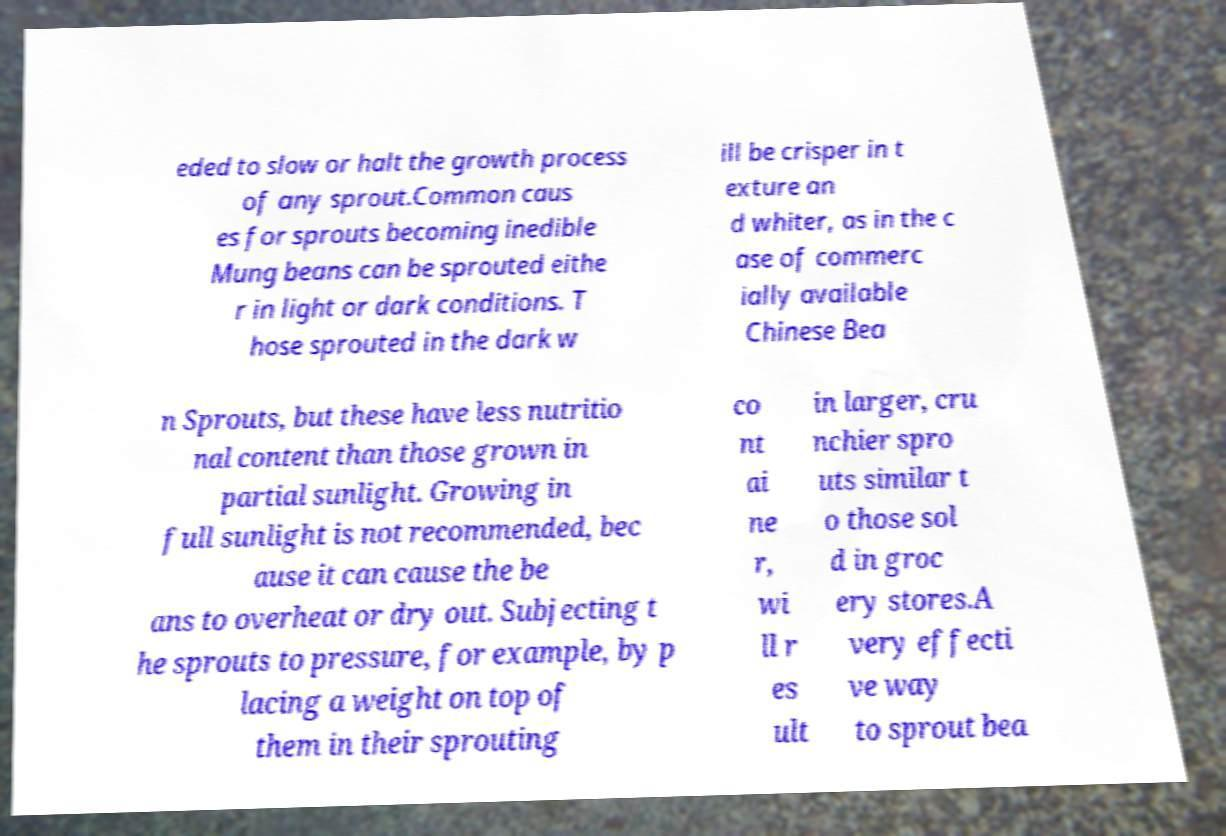Please identify and transcribe the text found in this image. eded to slow or halt the growth process of any sprout.Common caus es for sprouts becoming inedible Mung beans can be sprouted eithe r in light or dark conditions. T hose sprouted in the dark w ill be crisper in t exture an d whiter, as in the c ase of commerc ially available Chinese Bea n Sprouts, but these have less nutritio nal content than those grown in partial sunlight. Growing in full sunlight is not recommended, bec ause it can cause the be ans to overheat or dry out. Subjecting t he sprouts to pressure, for example, by p lacing a weight on top of them in their sprouting co nt ai ne r, wi ll r es ult in larger, cru nchier spro uts similar t o those sol d in groc ery stores.A very effecti ve way to sprout bea 